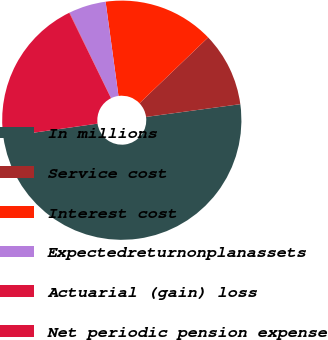Convert chart to OTSL. <chart><loc_0><loc_0><loc_500><loc_500><pie_chart><fcel>In millions<fcel>Service cost<fcel>Interest cost<fcel>Expectedreturnonplanassets<fcel>Actuarial (gain) loss<fcel>Net periodic pension expense<nl><fcel>49.9%<fcel>10.02%<fcel>15.0%<fcel>5.03%<fcel>0.05%<fcel>19.99%<nl></chart> 